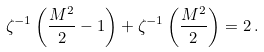<formula> <loc_0><loc_0><loc_500><loc_500>\zeta ^ { - 1 } \left ( \frac { M ^ { 2 } } { 2 } - 1 \right ) + \zeta ^ { - 1 } \left ( \frac { M ^ { 2 } } { 2 } \right ) = 2 \, .</formula> 